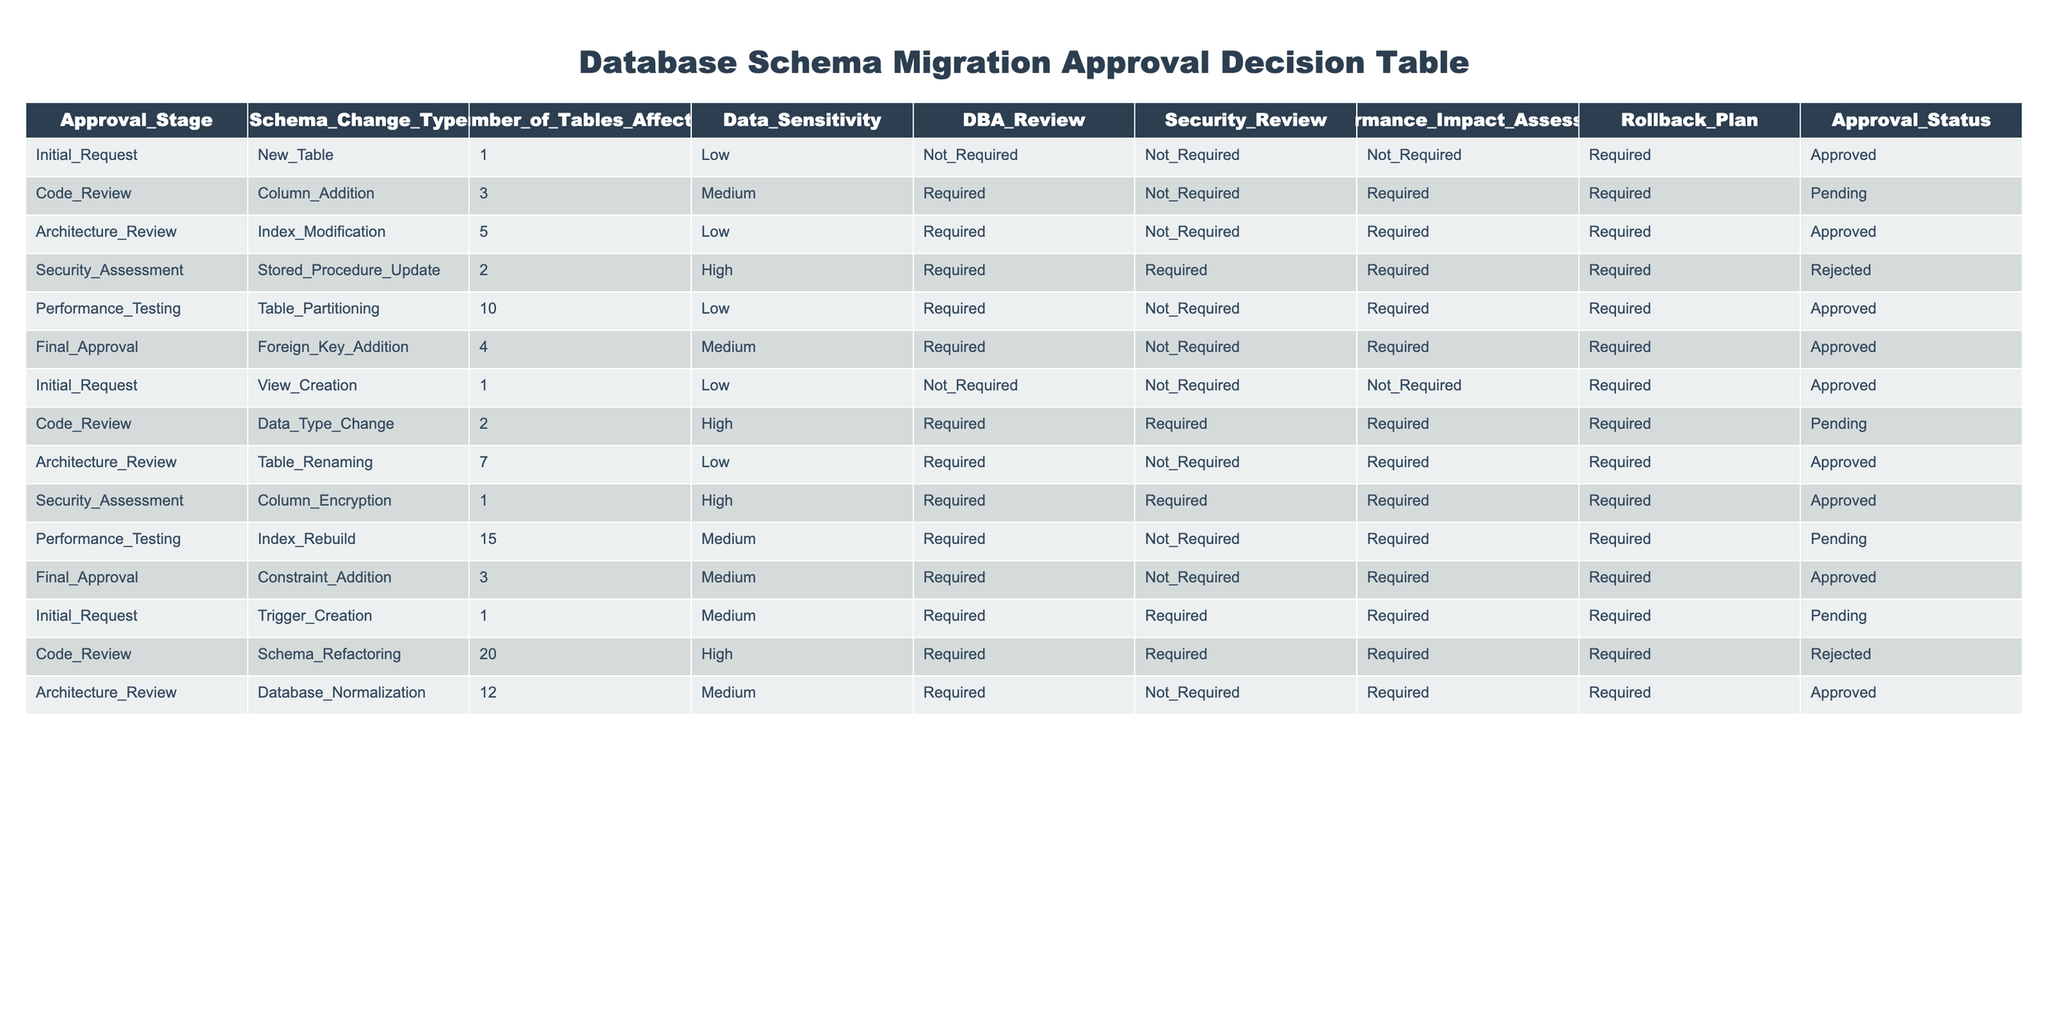What is the approval status of the stored procedure update? The table shows that the stored procedure update in the security assessment stage has an approval status of "Rejected."
Answer: Rejected How many tables are affected by the trigger creation? According to the table, the trigger creation in the initial request stage affects 1 table.
Answer: 1 What is the approval status for all schema change types that have a medium data sensitivity level? The table includes multiple entries with medium data sensitivity: column addition (pending), foreign key addition (approved), and constraint addition (approved). Since two out of three have been approved, there is a mix of approval statuses.
Answer: Mixed What is the total number of tables affected across all schema change requests? Summing the number of tables affected: 1 (new table) + 3 (column addition) + 5 (index modification) + 2 (stored procedure update) + 10 (table partitioning) + 4 (foreign key addition) + 1 (view creation) + 2 (data type change) + 7 (table renaming) + 1 (column encryption) + 15 (index rebuild) + 3 (constraint addition) + 1 (trigger creation) + 20 (schema refactoring) + 12 (database normalization) gives a total of 73 tables affected.
Answer: 73 Are all schema changes that require a rollback plan approved? The table shows that approvals can vary even if a rollback plan is required: examples include the index modification (approved) and stored procedure update (rejected), indicating that not all schema changes requiring a rollback plan are approved.
Answer: No Which schema change type has the highest number of tables affected and what is its approval status? The schema change type with the highest number of tables affected is the schema refactoring, which affects 20 tables and has an approval status of "Rejected."
Answer: Schema refactoring, Rejected 